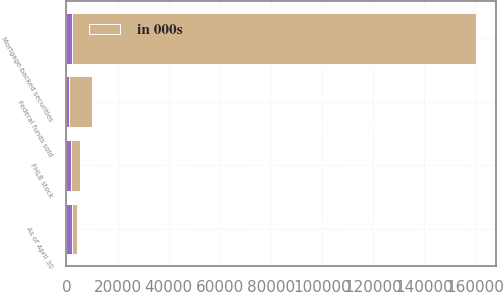Convert chart. <chart><loc_0><loc_0><loc_500><loc_500><stacked_bar_chart><ecel><fcel>As of April 30<fcel>Mortgage-backed securities<fcel>Federal funds sold<fcel>FHLB stock<nl><fcel>nan<fcel>2013<fcel>2013<fcel>1169<fcel>1861<nl><fcel>in 000s<fcel>2011<fcel>158177<fcel>8727<fcel>3315<nl></chart> 